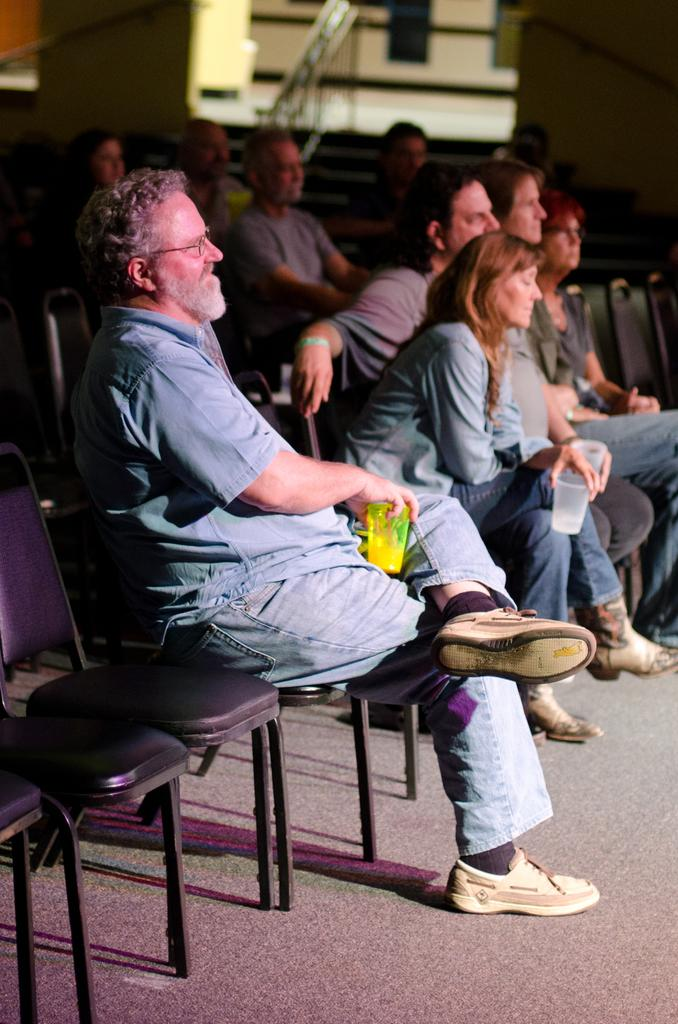What is the main subject of the image? The main subject of the image is a group of people. What are some of the people in the group doing? Some of the people in the group are sitting on chairs. What objects are being held by some of the people in the group? Some people in the group are holding glasses in their hands. What type of decision can be seen on the stage in the image? There is no stage present in the image, and therefore no decision can be seen. 